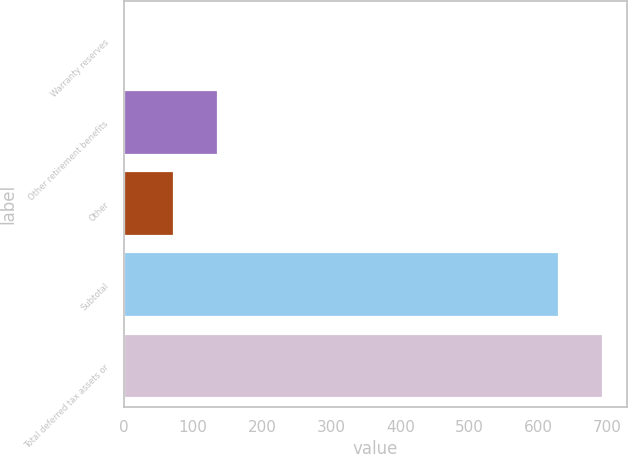<chart> <loc_0><loc_0><loc_500><loc_500><bar_chart><fcel>Warranty reserves<fcel>Other retirement benefits<fcel>Other<fcel>Subtotal<fcel>Total deferred tax assets or<nl><fcel>1<fcel>135.9<fcel>73<fcel>630<fcel>692.9<nl></chart> 